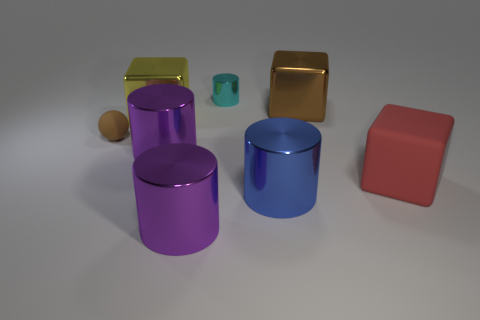Add 1 tiny purple things. How many objects exist? 9 Subtract all balls. How many objects are left? 7 Subtract 1 cyan cylinders. How many objects are left? 7 Subtract all large blue spheres. Subtract all big yellow metal things. How many objects are left? 7 Add 8 blue things. How many blue things are left? 9 Add 5 metallic cubes. How many metallic cubes exist? 7 